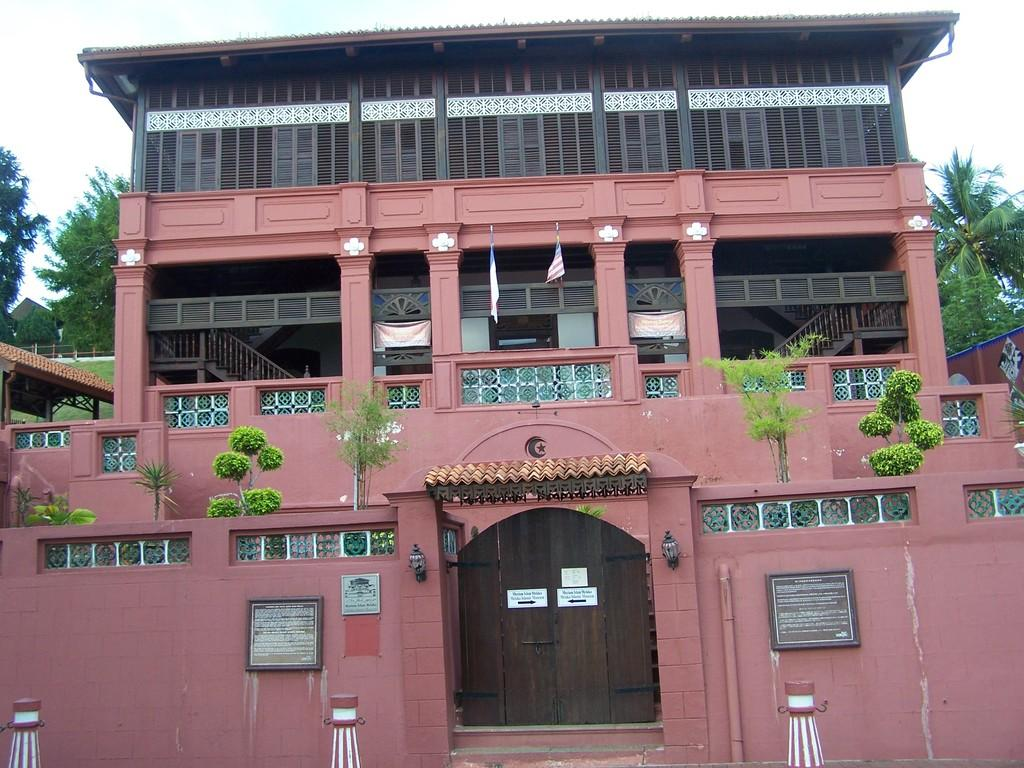What structure is the main subject of the image? There is a building in the image. What can be seen on the building? There are plants on the building and boards on the wall. What is visible in the background of the image? There are trees and the sky visible in the background. How can someone enter the building? There is a door in the image. What type of plastic is being used to generate heat in the image? There is no plastic or heat generation present in the image. Can you describe the kiss between the two people in the image? There are no people or kisses depicted in the image; it features a building with plants and boards on the wall. 